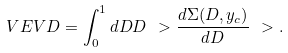Convert formula to latex. <formula><loc_0><loc_0><loc_500><loc_500>\ V E V { D } = \int _ { 0 } ^ { 1 } d D D \ > \frac { d \Sigma ( D , y _ { c } ) } { d D } \ > .</formula> 